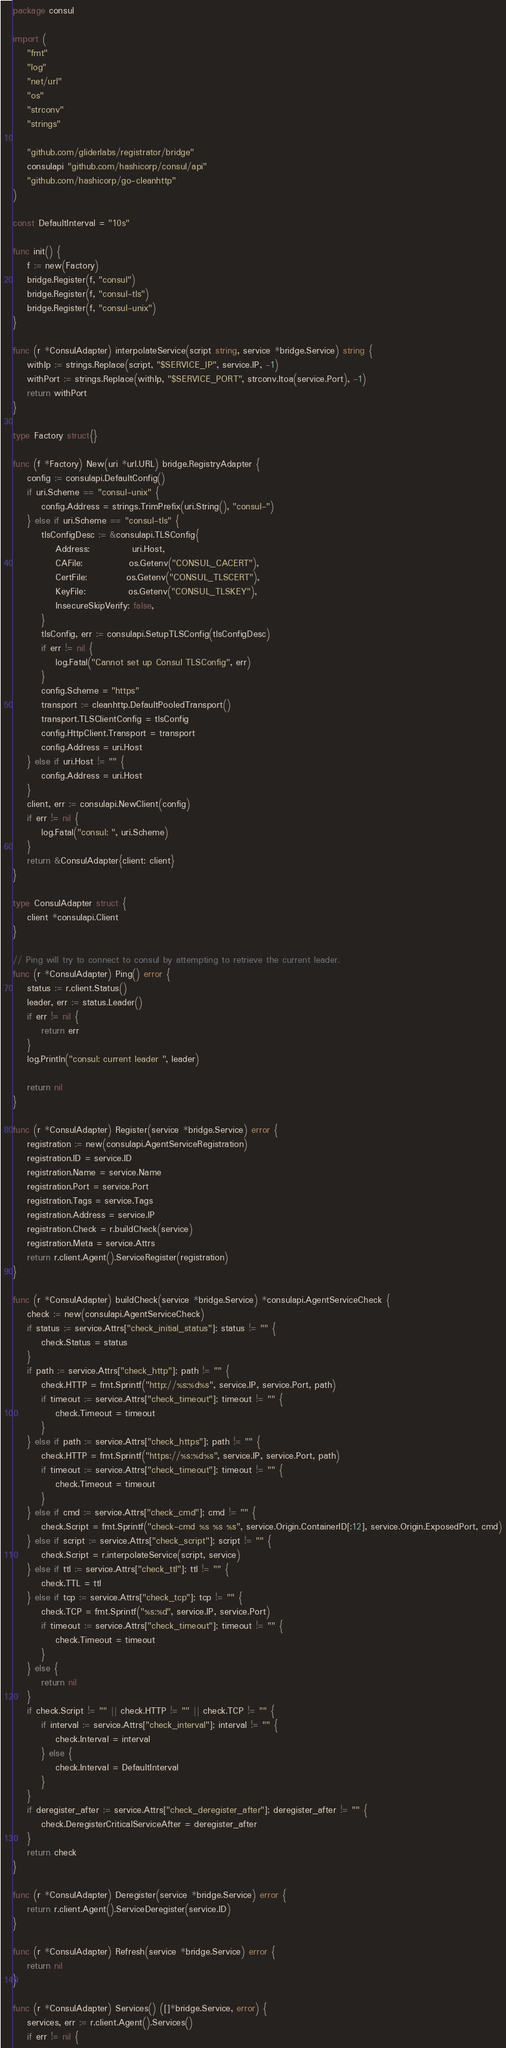<code> <loc_0><loc_0><loc_500><loc_500><_Go_>package consul

import (
	"fmt"
	"log"
	"net/url"
	"os"
	"strconv"
	"strings"

	"github.com/gliderlabs/registrator/bridge"
	consulapi "github.com/hashicorp/consul/api"
	"github.com/hashicorp/go-cleanhttp"
)

const DefaultInterval = "10s"

func init() {
	f := new(Factory)
	bridge.Register(f, "consul")
	bridge.Register(f, "consul-tls")
	bridge.Register(f, "consul-unix")
}

func (r *ConsulAdapter) interpolateService(script string, service *bridge.Service) string {
	withIp := strings.Replace(script, "$SERVICE_IP", service.IP, -1)
	withPort := strings.Replace(withIp, "$SERVICE_PORT", strconv.Itoa(service.Port), -1)
	return withPort
}

type Factory struct{}

func (f *Factory) New(uri *url.URL) bridge.RegistryAdapter {
	config := consulapi.DefaultConfig()
	if uri.Scheme == "consul-unix" {
		config.Address = strings.TrimPrefix(uri.String(), "consul-")
	} else if uri.Scheme == "consul-tls" {
		tlsConfigDesc := &consulapi.TLSConfig{
			Address:            uri.Host,
			CAFile:             os.Getenv("CONSUL_CACERT"),
			CertFile:           os.Getenv("CONSUL_TLSCERT"),
			KeyFile:            os.Getenv("CONSUL_TLSKEY"),
			InsecureSkipVerify: false,
		}
		tlsConfig, err := consulapi.SetupTLSConfig(tlsConfigDesc)
		if err != nil {
			log.Fatal("Cannot set up Consul TLSConfig", err)
		}
		config.Scheme = "https"
		transport := cleanhttp.DefaultPooledTransport()
		transport.TLSClientConfig = tlsConfig
		config.HttpClient.Transport = transport
		config.Address = uri.Host
	} else if uri.Host != "" {
		config.Address = uri.Host
	}
	client, err := consulapi.NewClient(config)
	if err != nil {
		log.Fatal("consul: ", uri.Scheme)
	}
	return &ConsulAdapter{client: client}
}

type ConsulAdapter struct {
	client *consulapi.Client
}

// Ping will try to connect to consul by attempting to retrieve the current leader.
func (r *ConsulAdapter) Ping() error {
	status := r.client.Status()
	leader, err := status.Leader()
	if err != nil {
		return err
	}
	log.Println("consul: current leader ", leader)

	return nil
}

func (r *ConsulAdapter) Register(service *bridge.Service) error {
	registration := new(consulapi.AgentServiceRegistration)
	registration.ID = service.ID
	registration.Name = service.Name
	registration.Port = service.Port
	registration.Tags = service.Tags
	registration.Address = service.IP
	registration.Check = r.buildCheck(service)
	registration.Meta = service.Attrs
	return r.client.Agent().ServiceRegister(registration)
}

func (r *ConsulAdapter) buildCheck(service *bridge.Service) *consulapi.AgentServiceCheck {
	check := new(consulapi.AgentServiceCheck)
	if status := service.Attrs["check_initial_status"]; status != "" {
		check.Status = status
	}
	if path := service.Attrs["check_http"]; path != "" {
		check.HTTP = fmt.Sprintf("http://%s:%d%s", service.IP, service.Port, path)
		if timeout := service.Attrs["check_timeout"]; timeout != "" {
			check.Timeout = timeout
		}
	} else if path := service.Attrs["check_https"]; path != "" {
		check.HTTP = fmt.Sprintf("https://%s:%d%s", service.IP, service.Port, path)
		if timeout := service.Attrs["check_timeout"]; timeout != "" {
			check.Timeout = timeout
		}
	} else if cmd := service.Attrs["check_cmd"]; cmd != "" {
		check.Script = fmt.Sprintf("check-cmd %s %s %s", service.Origin.ContainerID[:12], service.Origin.ExposedPort, cmd)
	} else if script := service.Attrs["check_script"]; script != "" {
		check.Script = r.interpolateService(script, service)
	} else if ttl := service.Attrs["check_ttl"]; ttl != "" {
		check.TTL = ttl
	} else if tcp := service.Attrs["check_tcp"]; tcp != "" {
		check.TCP = fmt.Sprintf("%s:%d", service.IP, service.Port)
		if timeout := service.Attrs["check_timeout"]; timeout != "" {
			check.Timeout = timeout
		}
	} else {
		return nil
	}
	if check.Script != "" || check.HTTP != "" || check.TCP != "" {
		if interval := service.Attrs["check_interval"]; interval != "" {
			check.Interval = interval
		} else {
			check.Interval = DefaultInterval
		}
	}
	if deregister_after := service.Attrs["check_deregister_after"]; deregister_after != "" {
		check.DeregisterCriticalServiceAfter = deregister_after
	}
	return check
}

func (r *ConsulAdapter) Deregister(service *bridge.Service) error {
	return r.client.Agent().ServiceDeregister(service.ID)
}

func (r *ConsulAdapter) Refresh(service *bridge.Service) error {
	return nil
}

func (r *ConsulAdapter) Services() ([]*bridge.Service, error) {
	services, err := r.client.Agent().Services()
	if err != nil {</code> 